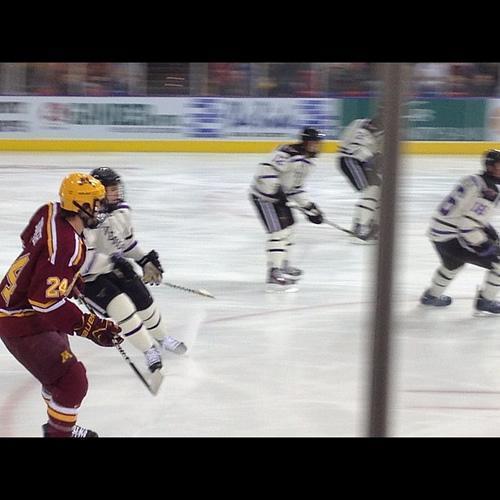How many players are there?
Give a very brief answer. 5. How many red jerseys are there?
Give a very brief answer. 1. 